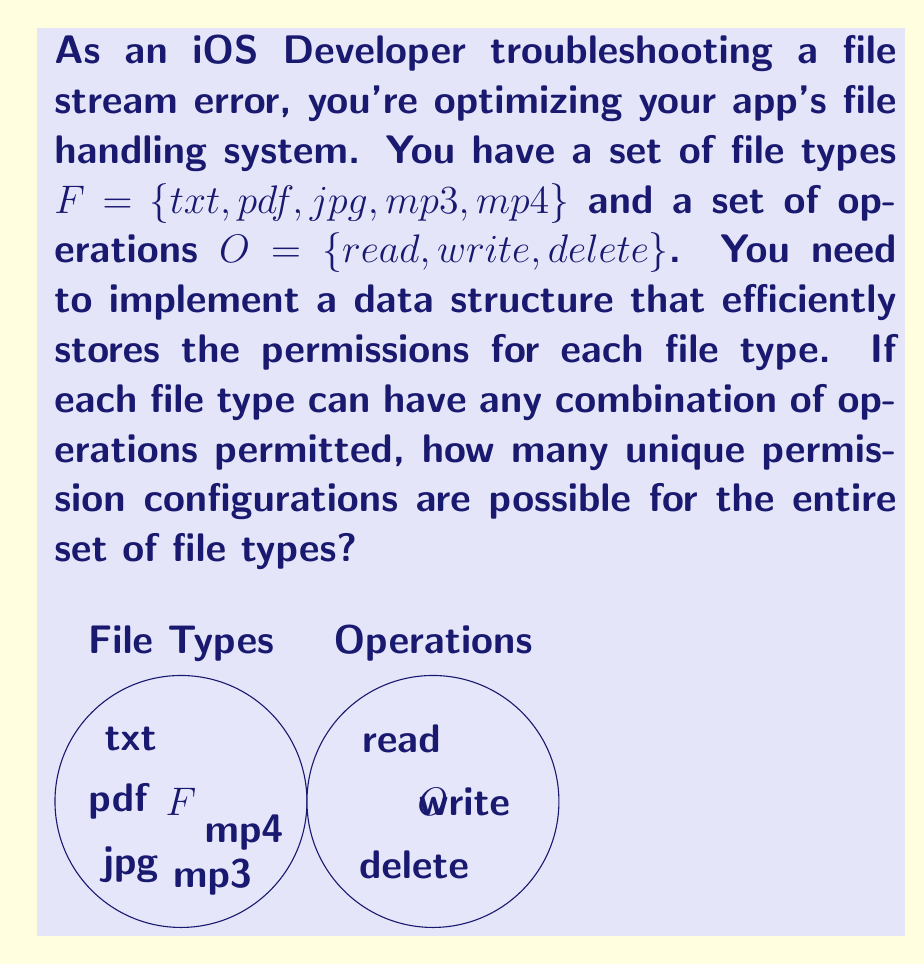Give your solution to this math problem. Let's approach this step-by-step:

1) First, we need to understand what the question is asking. For each file type, we need to determine how many different permission configurations are possible.

2) For each file type, we have three operations: read, write, and delete. Each operation can be either permitted or not permitted.

3) This scenario can be modeled using set theory. For each file type, we're essentially creating a subset of the operations set $O$.

4) The number of possible subsets for a set with $n$ elements is $2^n$. This is because for each element, we have two choices: include it or not.

5) In our case, $|O| = 3$ (the number of operations). So for each file type, we have $2^3 = 8$ possible permission configurations.

6) Now, we need to consider this for all file types. We have 5 file types, and each can have 8 different configurations.

7) When we have independent choices like this, we multiply the number of possibilities. This is the multiplication principle in combinatorics.

8) Therefore, the total number of unique permission configurations for all file types is:

   $$8^5 = 32,768$$

This represents all possible ways to assign permissions to the file types, where each file type can have any combination of the three operations permitted or not permitted.
Answer: $32,768$ 